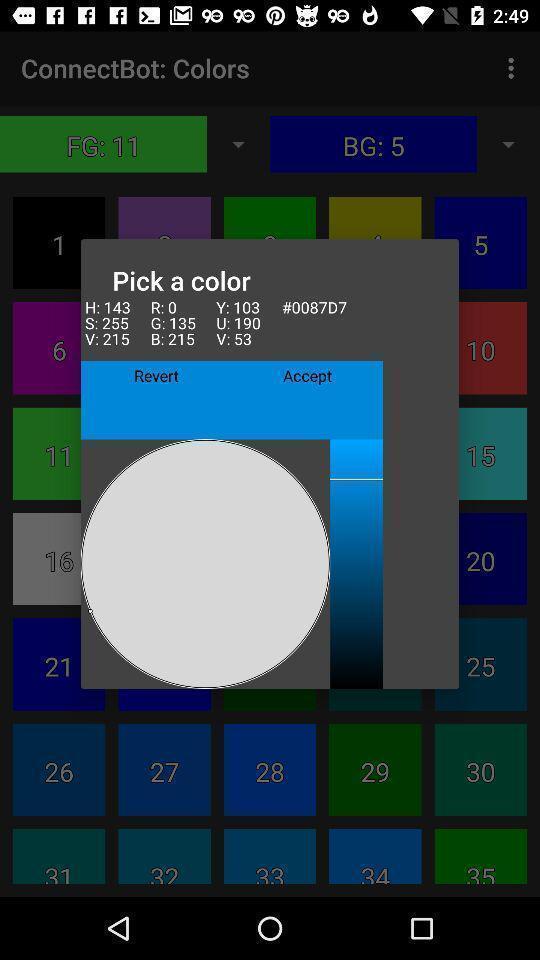Summarize the main components in this picture. Pop up scree of pick a color. 